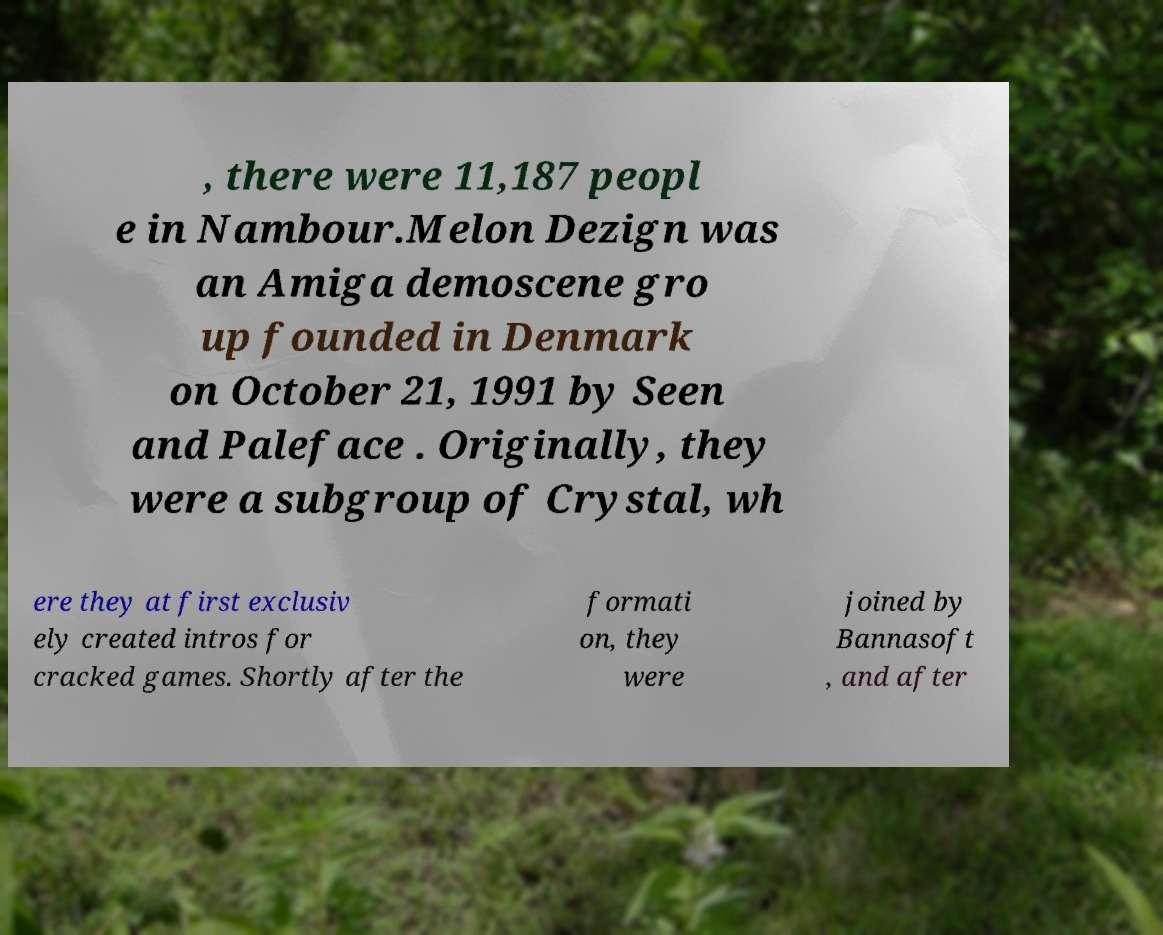There's text embedded in this image that I need extracted. Can you transcribe it verbatim? , there were 11,187 peopl e in Nambour.Melon Dezign was an Amiga demoscene gro up founded in Denmark on October 21, 1991 by Seen and Paleface . Originally, they were a subgroup of Crystal, wh ere they at first exclusiv ely created intros for cracked games. Shortly after the formati on, they were joined by Bannasoft , and after 